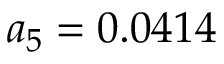Convert formula to latex. <formula><loc_0><loc_0><loc_500><loc_500>a _ { 5 } = 0 . 0 4 1 4</formula> 